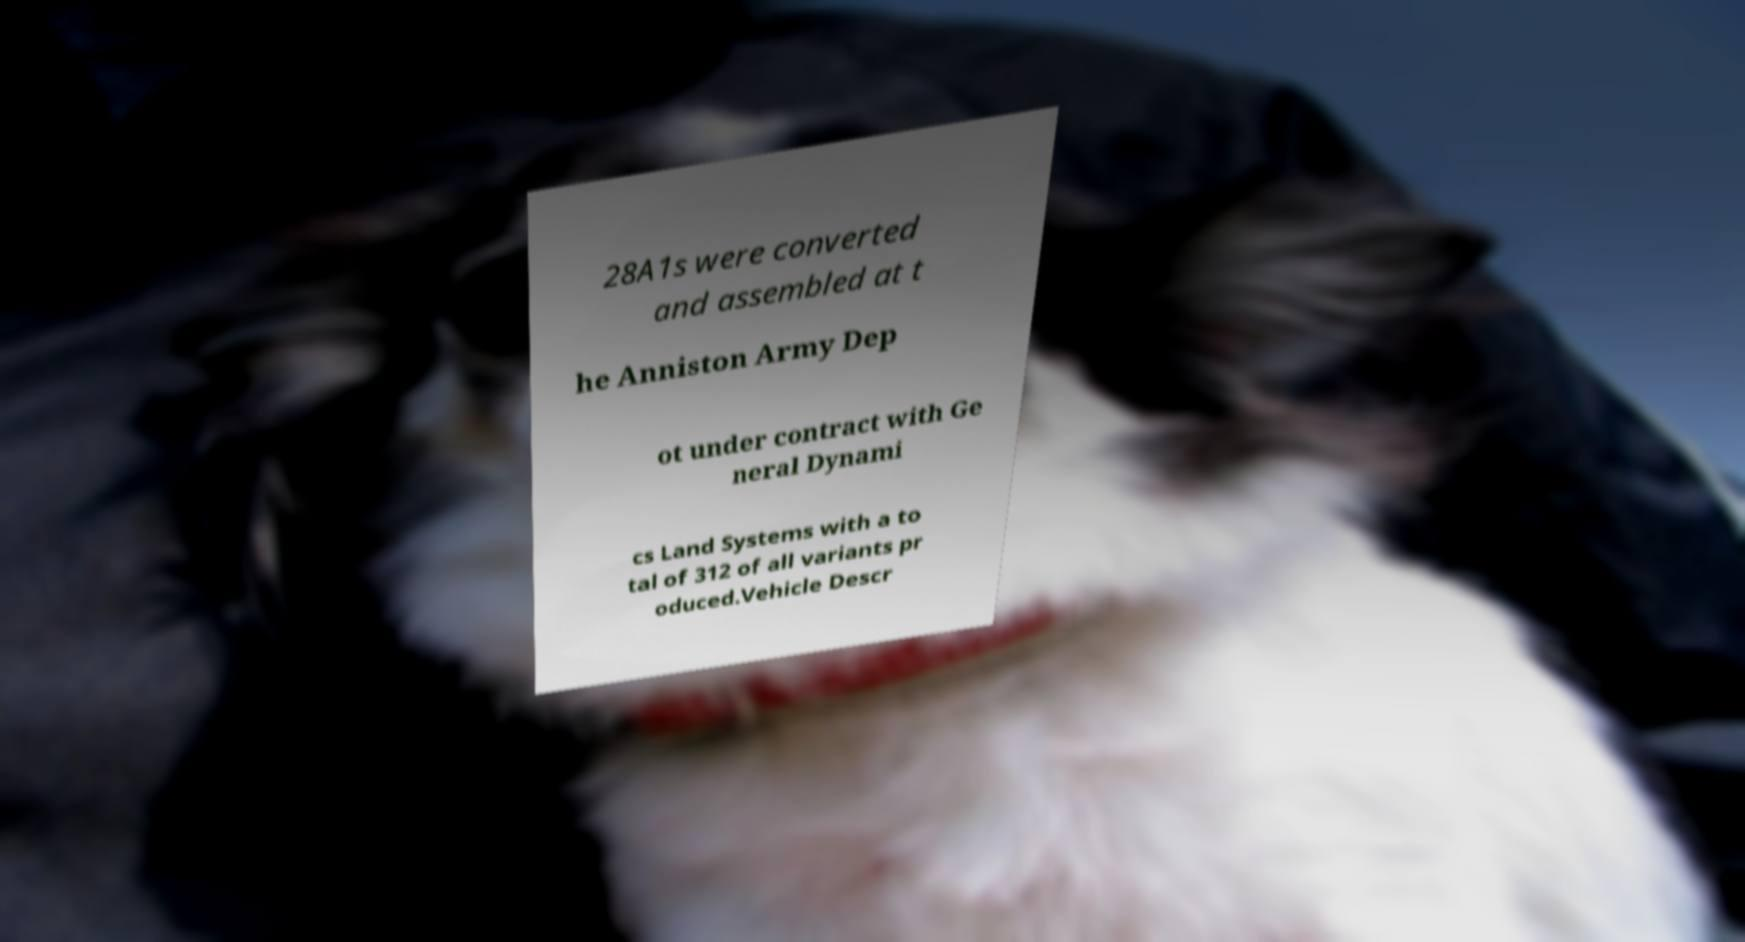For documentation purposes, I need the text within this image transcribed. Could you provide that? 28A1s were converted and assembled at t he Anniston Army Dep ot under contract with Ge neral Dynami cs Land Systems with a to tal of 312 of all variants pr oduced.Vehicle Descr 